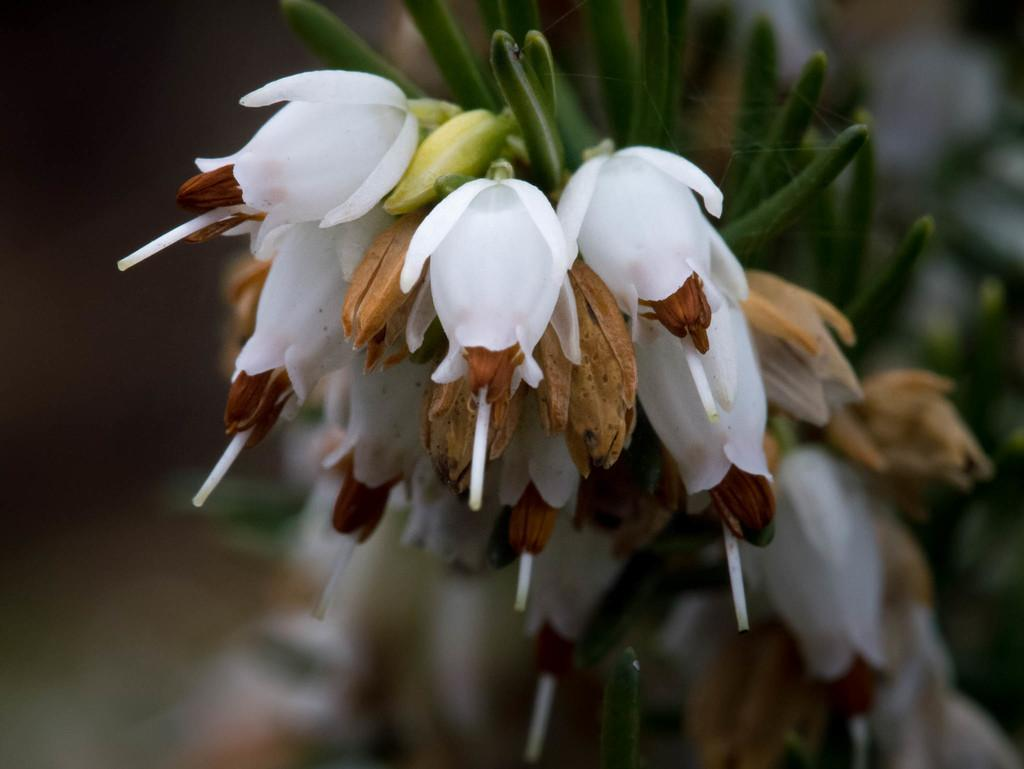What is the main subject of the image? There is a flower in the image. What type of meal is being prepared in the image? There is no meal or food preparation visible in the image; it features a flower. What is located on the back of the flower in the image? There is no reference to a back or any other part of the flower in the image, as it only shows the flower itself. 